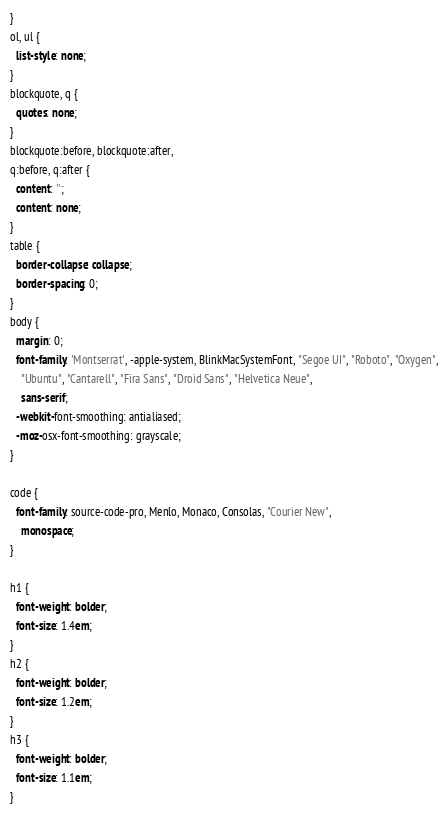Convert code to text. <code><loc_0><loc_0><loc_500><loc_500><_CSS_>}
ol, ul {
  list-style: none;
}
blockquote, q {
  quotes: none;
}
blockquote:before, blockquote:after,
q:before, q:after {
  content: '';
  content: none;
}
table {
  border-collapse: collapse;
  border-spacing: 0;
}
body {
  margin: 0;
  font-family: 'Montserrat', -apple-system, BlinkMacSystemFont, "Segoe UI", "Roboto", "Oxygen",
    "Ubuntu", "Cantarell", "Fira Sans", "Droid Sans", "Helvetica Neue",
    sans-serif;
  -webkit-font-smoothing: antialiased;
  -moz-osx-font-smoothing: grayscale;
}

code {
  font-family: source-code-pro, Menlo, Monaco, Consolas, "Courier New",
    monospace;
}

h1 {
  font-weight: bolder;
  font-size: 1.4em;
}
h2 {
  font-weight: bolder;
  font-size: 1.2em;
}
h3 {
  font-weight: bolder;
  font-size: 1.1em;
}
</code> 